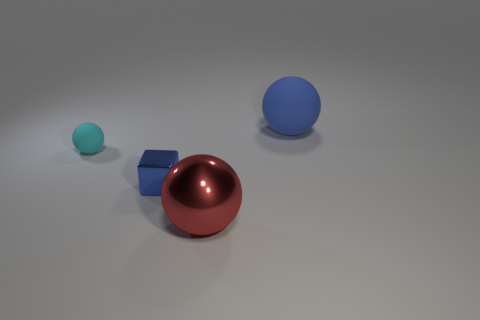Are there any large cyan objects made of the same material as the tiny cyan ball?
Keep it short and to the point. No. How many objects are big blue rubber spheres or big metal things?
Offer a terse response. 2. Is the material of the tiny cyan sphere the same as the big blue object to the right of the small matte ball?
Ensure brevity in your answer.  Yes. There is a sphere behind the tiny cyan thing; what is its size?
Your response must be concise. Large. Is the number of small cyan cylinders less than the number of blue metal objects?
Your answer should be compact. Yes. Is there another shiny cube that has the same color as the small metallic cube?
Give a very brief answer. No. What is the shape of the thing that is both behind the metallic cube and to the left of the blue matte sphere?
Your answer should be compact. Sphere. There is a matte thing to the left of the tiny cube that is in front of the small cyan object; what is its shape?
Keep it short and to the point. Sphere. Do the big red shiny thing and the cyan rubber object have the same shape?
Ensure brevity in your answer.  Yes. What is the material of the big ball that is the same color as the block?
Your answer should be very brief. Rubber. 